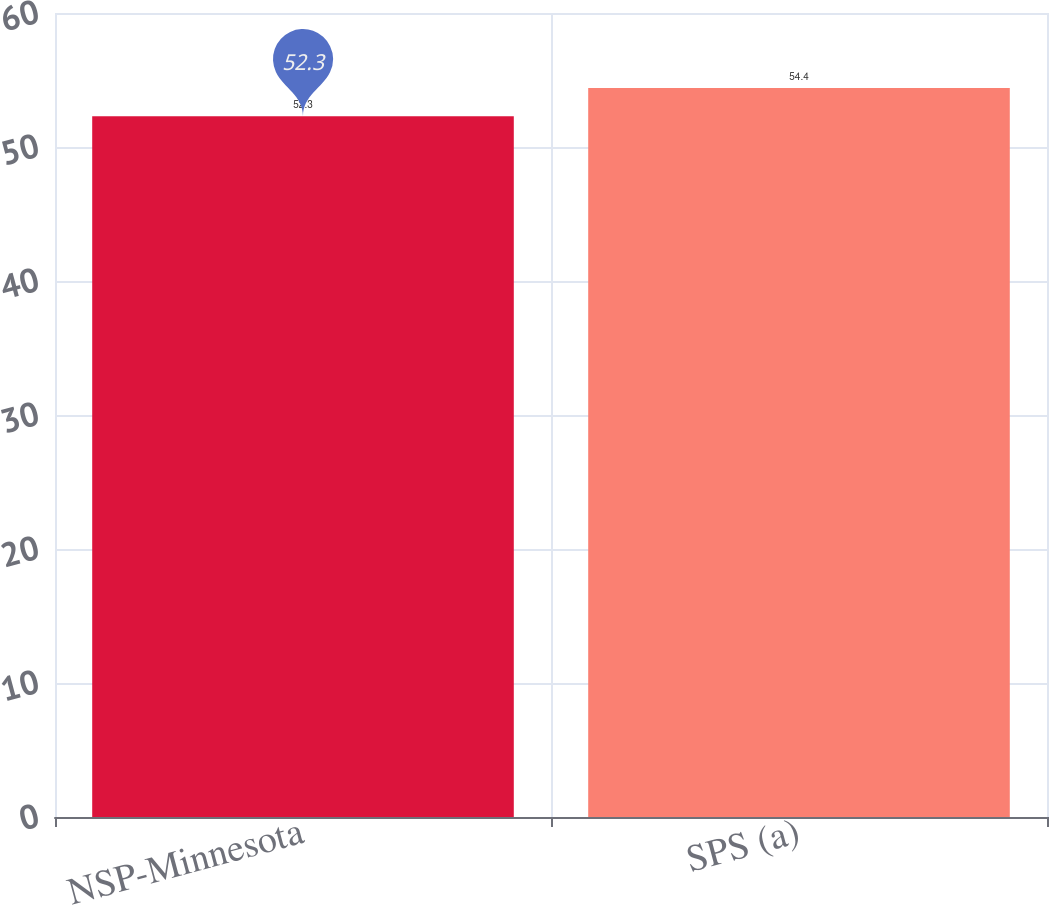<chart> <loc_0><loc_0><loc_500><loc_500><bar_chart><fcel>NSP-Minnesota<fcel>SPS (a)<nl><fcel>52.3<fcel>54.4<nl></chart> 